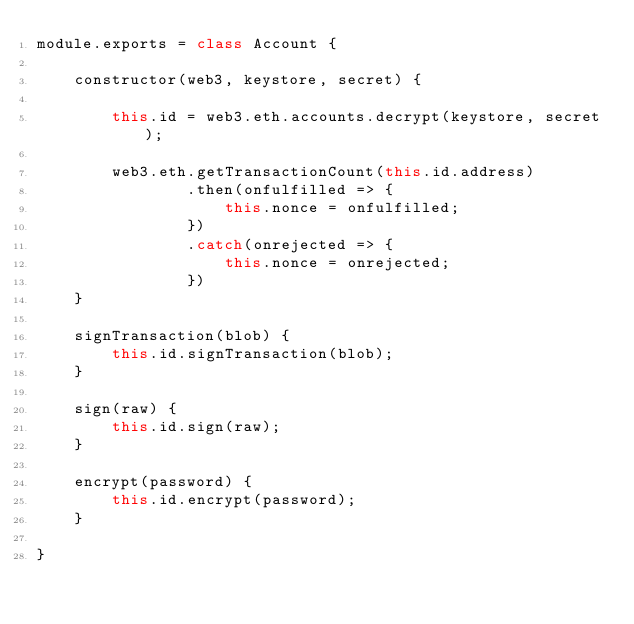<code> <loc_0><loc_0><loc_500><loc_500><_JavaScript_>module.exports = class Account {

    constructor(web3, keystore, secret) {

        this.id = web3.eth.accounts.decrypt(keystore, secret);

        web3.eth.getTransactionCount(this.id.address)
                .then(onfulfilled => {
                    this.nonce = onfulfilled;
                })
                .catch(onrejected => {
                    this.nonce = onrejected;
                })
    }

    signTransaction(blob) {
        this.id.signTransaction(blob);
    }

    sign(raw) {
        this.id.sign(raw);
    }

    encrypt(password) {
        this.id.encrypt(password);
    }

}</code> 